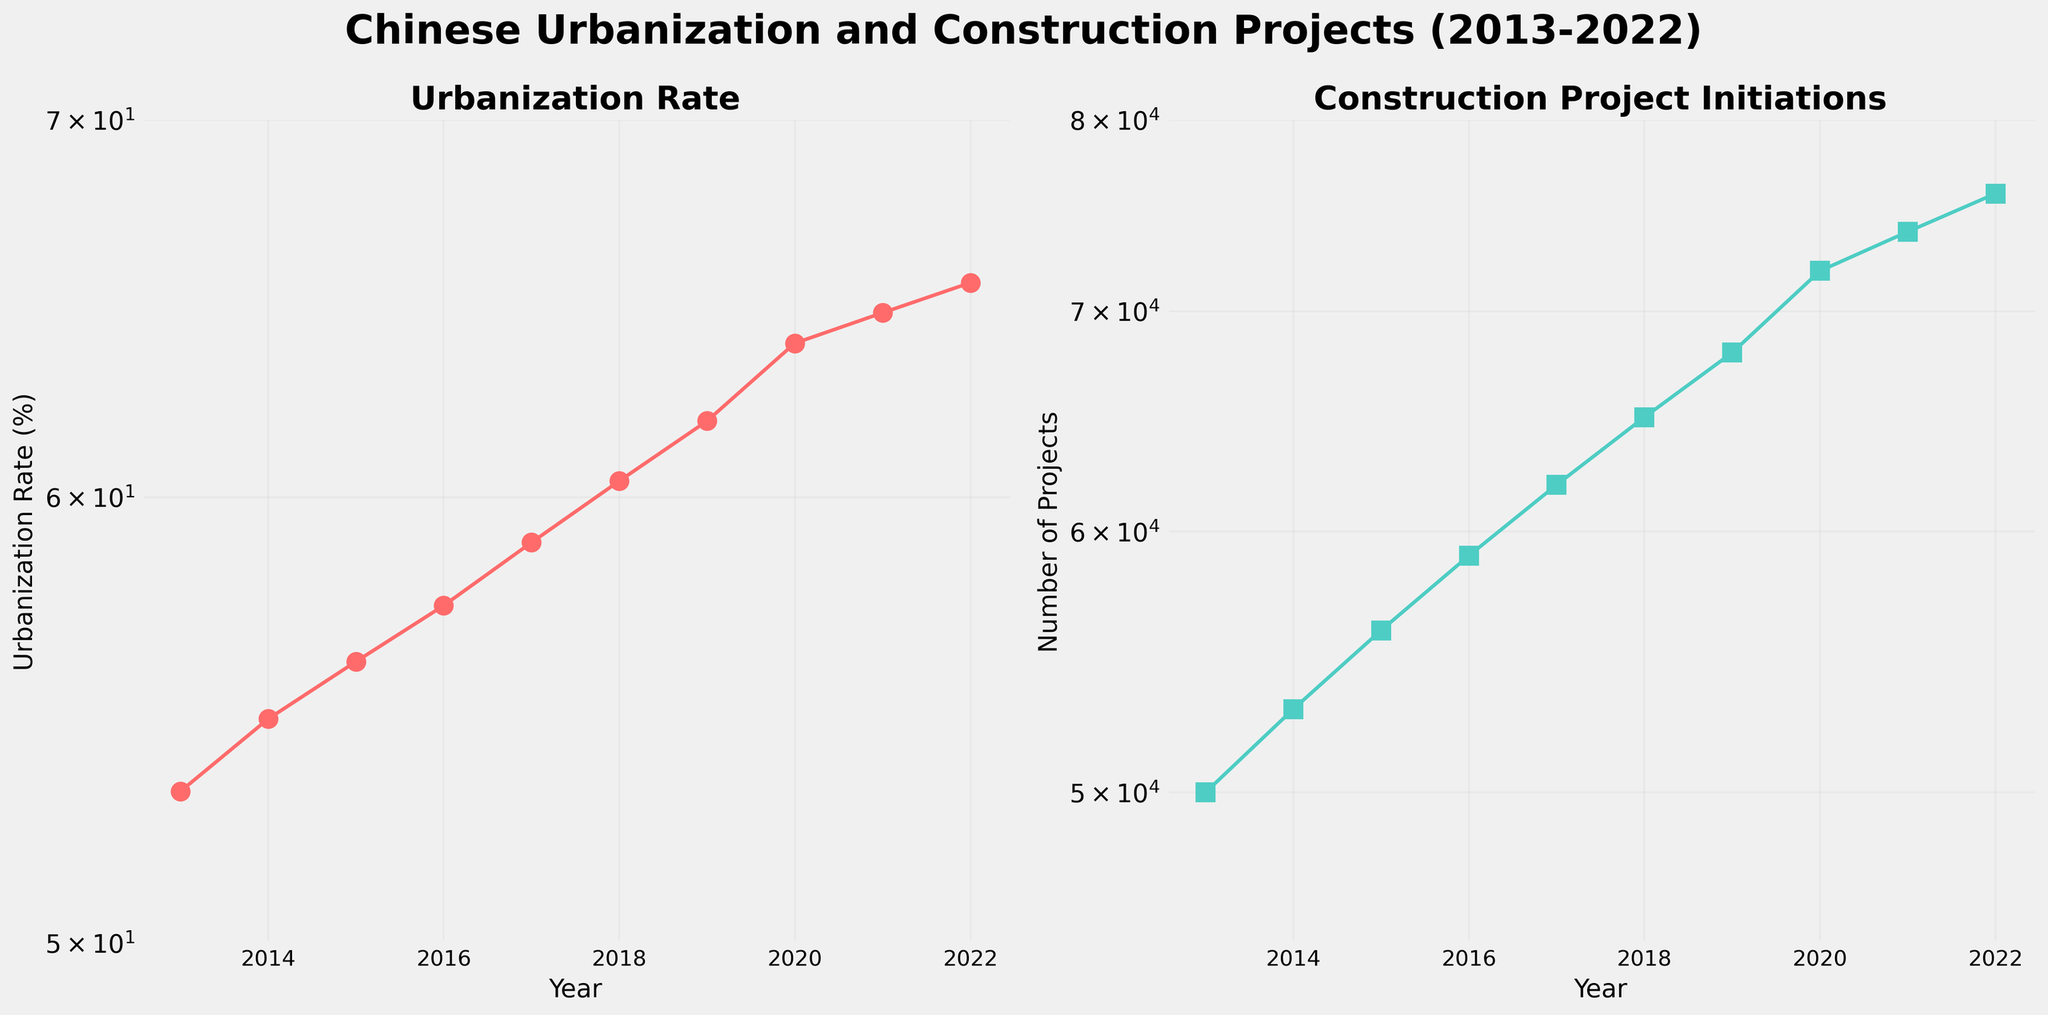How many subplots are in the figure? The figure contains two subplots. Each subplot has its own title and displays different data sets.
Answer: 2 What is the title of the left subplot? The title of the left subplot is "Urbanization Rate," as indicated at the top of the subplot.
Answer: Urbanization Rate What color is used for the data points on the right subplot? The data points on the right subplot are colored in a light blue-green shade.
Answer: Light blue-green Over what range of years does the data span? The x-axis on both subplots ranges from 2013 to 2022, showing the period over which the data was collected.
Answer: 2013 to 2022 What is the approximate urbanization rate in 2017? In 2017, the urbanization rate is around 58.9%, as observed by referencing the data point from the corresponding year on the left subplot.
Answer: 58.9% What trend can be observed in construction project initiations from 2013 to 2022? Construction project initiations show a consistent upward trend from about 50,000 in 2013 to 76,000 in 2022, as depicted by the steady rise of the line in the right subplot.
Answer: Upward trend How much did the urbanization rate increase between 2013 and 2022? The urbanization rate increased from 53.2% in 2013 to 65.5% in 2022. The difference is calculated as 65.5 - 53.2 = 12.3%.
Answer: 12.3% Which year experienced the largest increase in urbanization rate compared to the previous year? The year with the largest year-over-year increase in urbanization rate can be determined by comparing the differences between each consecutive year. The largest increase is from 2019 to 2020, where the rate increased from 61.9% to 63.9%, a difference of 2%.
Answer: 2019 to 2020 Based on the figures, are the urbanization rates higher or lower compared to the construction projects' numbers in a given year? Urbanization rates (percentage values) are numerically lower than the number of construction projects (absolute values) in any given year, as indicated by the y-axis values and the data points in both subplots.
Answer: Lower What kind of plot is used in both subplots, and why might this type of plot be chosen? Both subplots use a semi-log plot, where the y-axis is on a logarithmic scale. This type of plot is useful for visualizing data with a wide range of values and highlighting proportional differences over time.
Answer: Semi-log plot 